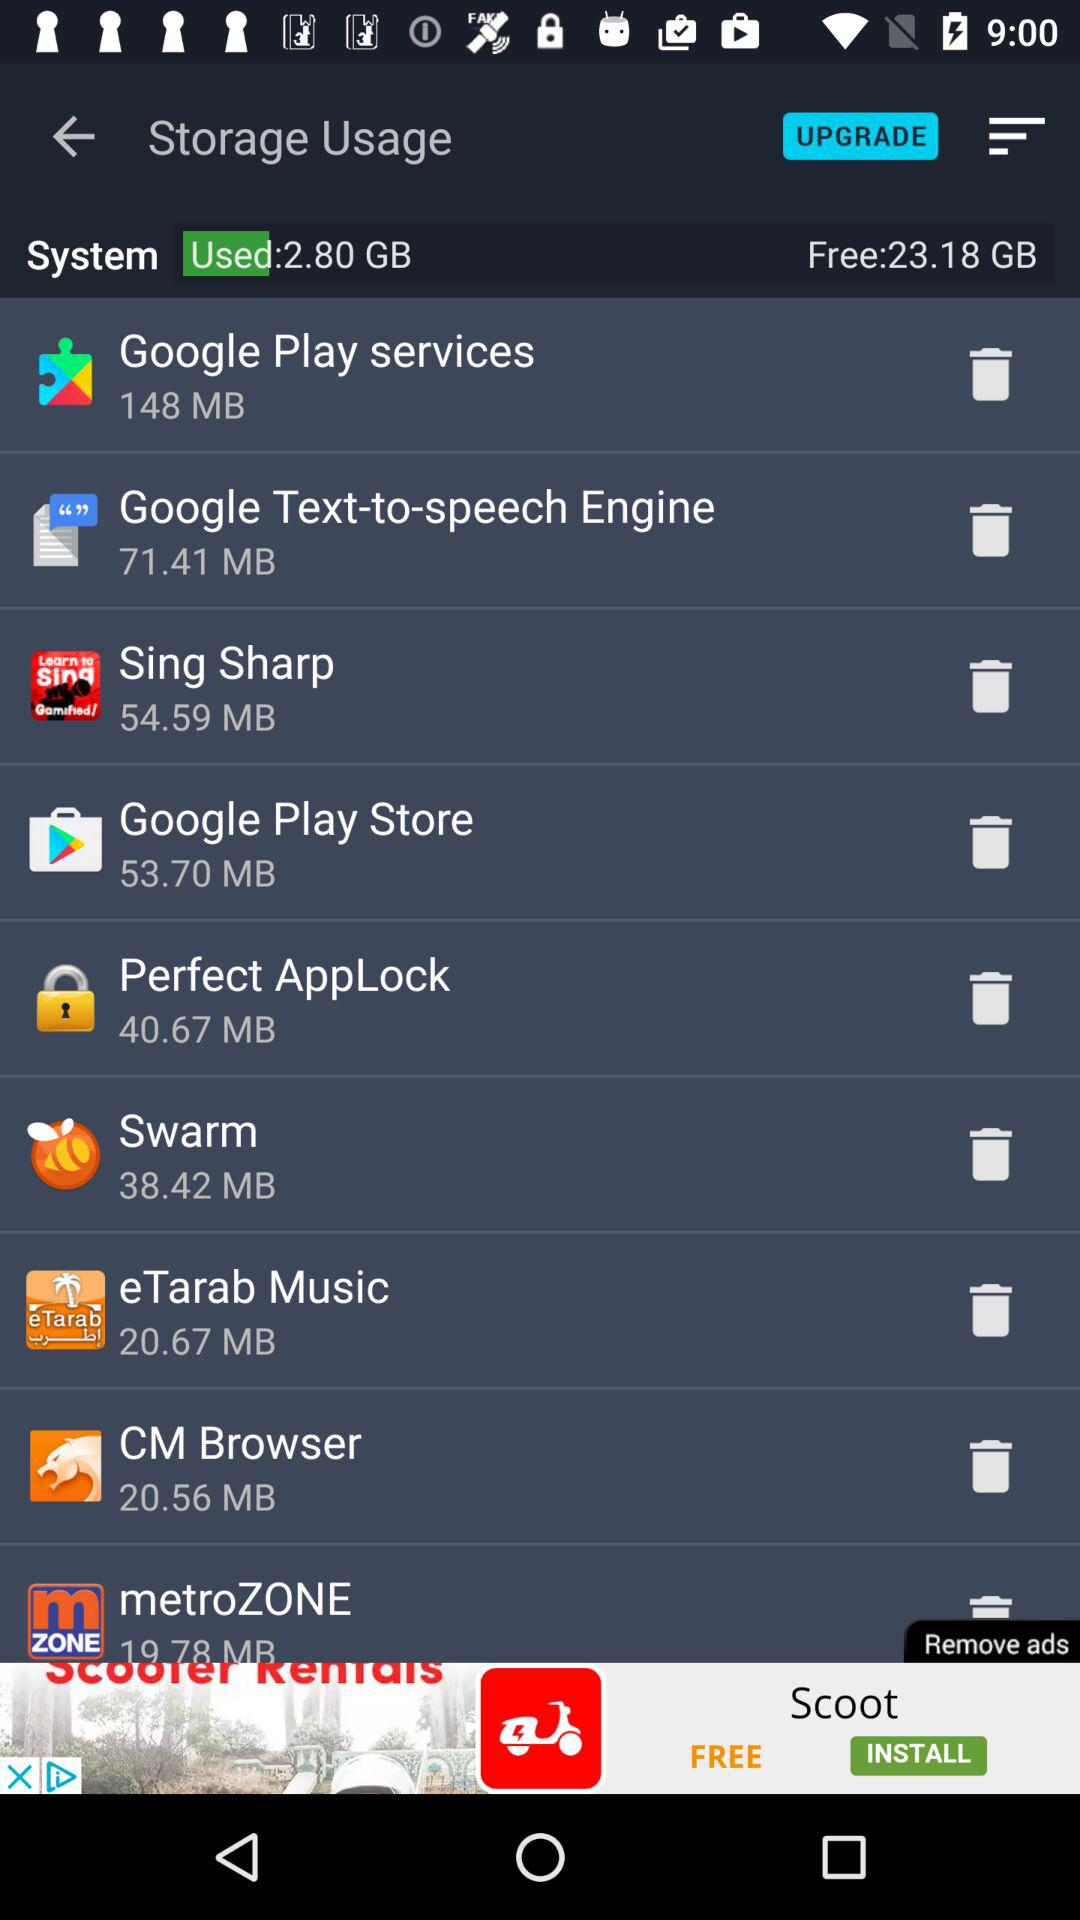Which app has the least amount of storage space used?
Answer the question using a single word or phrase. MetroZONE 